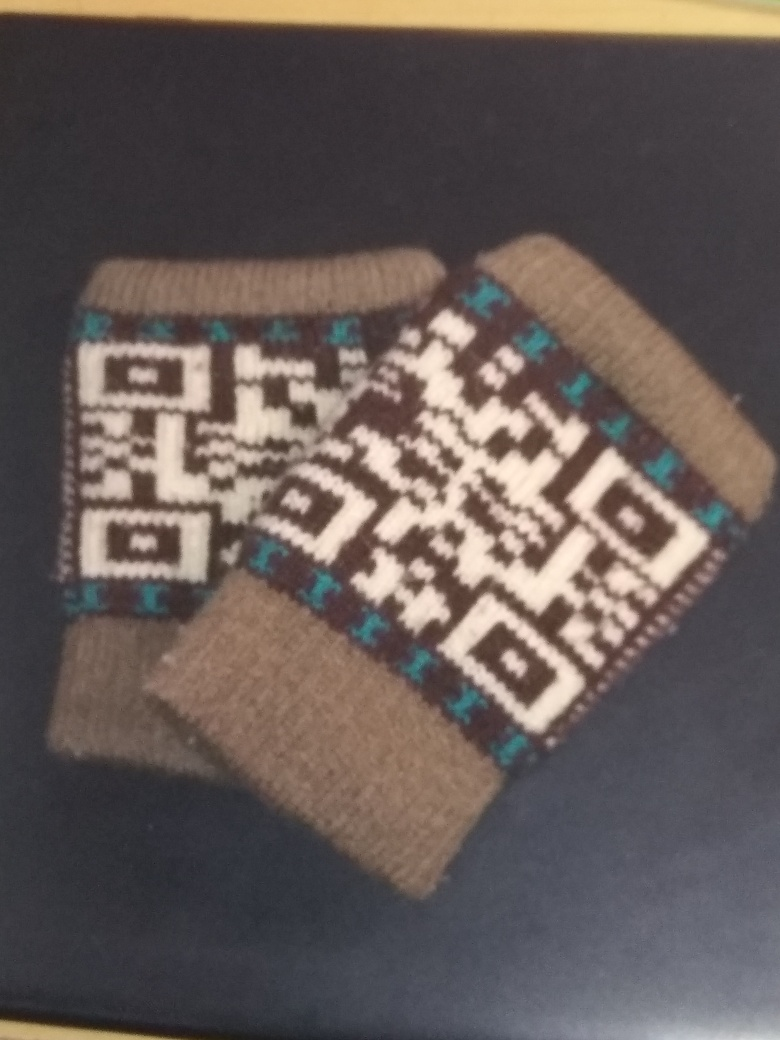What kind of item is shown in the image? The image displays a pair of cozy knitted socks with a geometric pattern typical of traditional craftsmanship. 